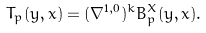<formula> <loc_0><loc_0><loc_500><loc_500>T _ { p } ( y , x ) = ( \nabla ^ { 1 , 0 } ) ^ { k } B _ { p } ^ { X } ( y , x ) .</formula> 